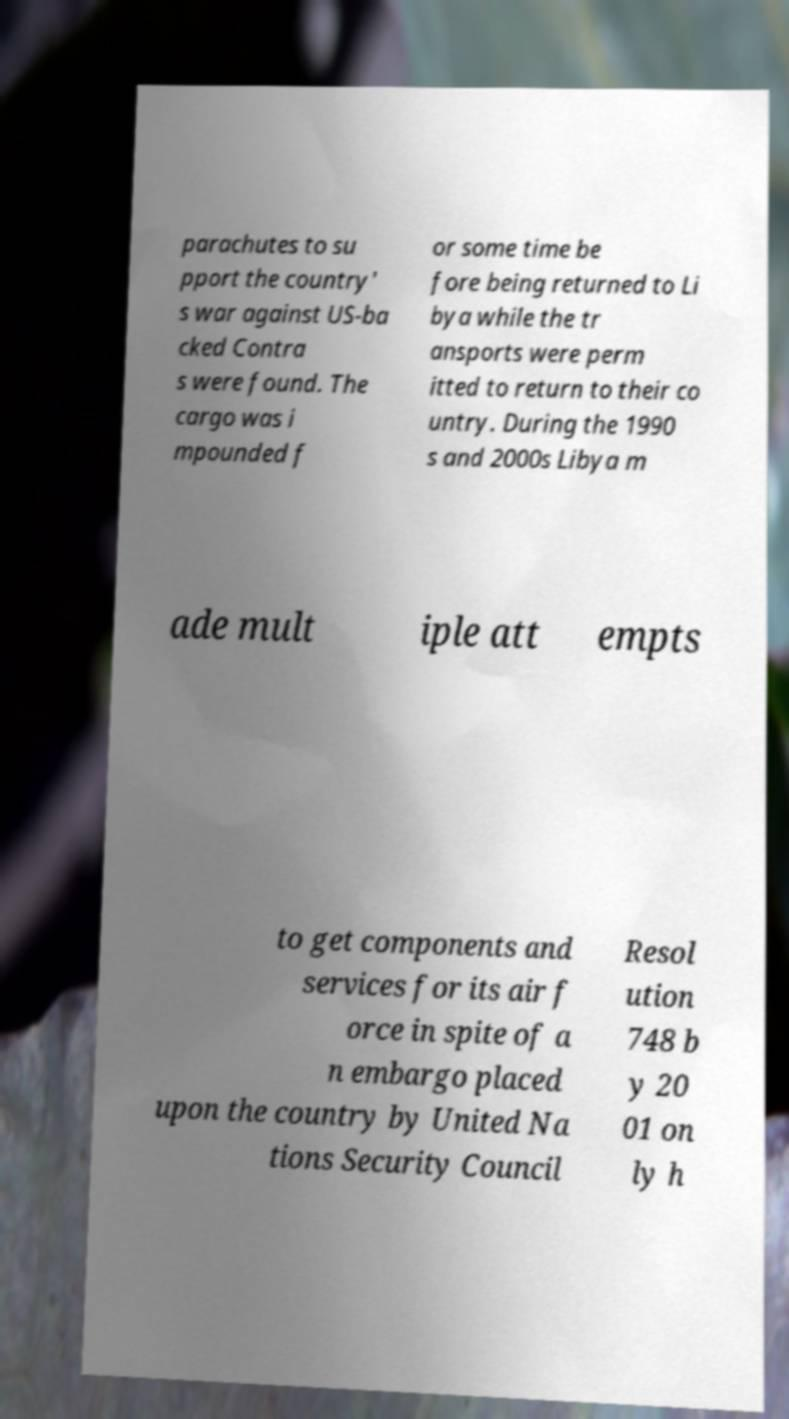Please identify and transcribe the text found in this image. parachutes to su pport the country' s war against US-ba cked Contra s were found. The cargo was i mpounded f or some time be fore being returned to Li bya while the tr ansports were perm itted to return to their co untry. During the 1990 s and 2000s Libya m ade mult iple att empts to get components and services for its air f orce in spite of a n embargo placed upon the country by United Na tions Security Council Resol ution 748 b y 20 01 on ly h 